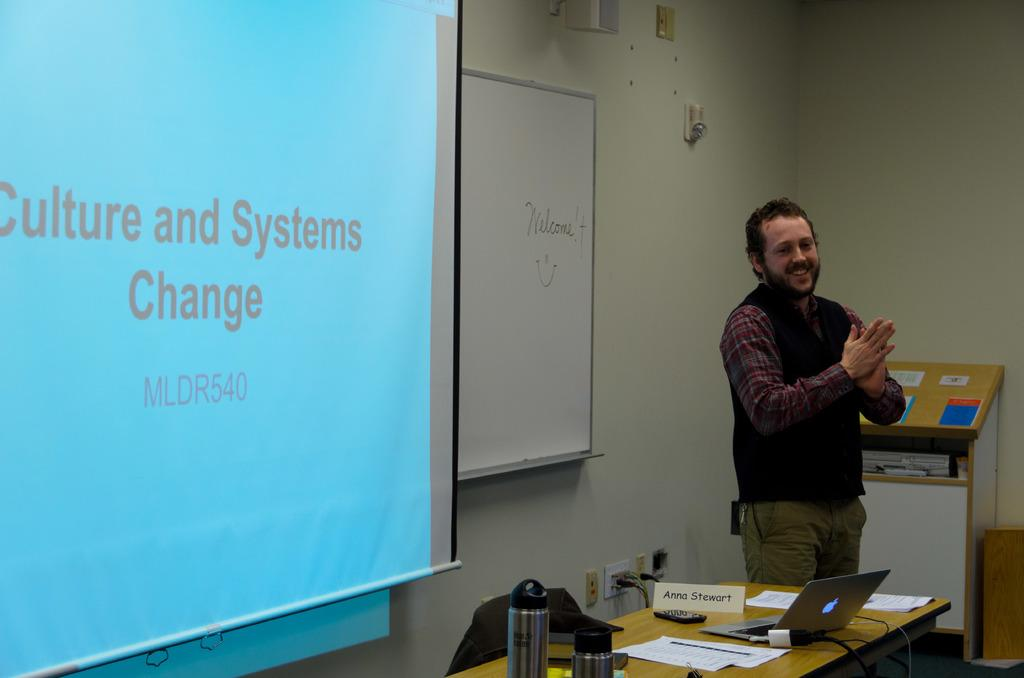Provide a one-sentence caption for the provided image. A man is giving a lecture on culture and system change. 